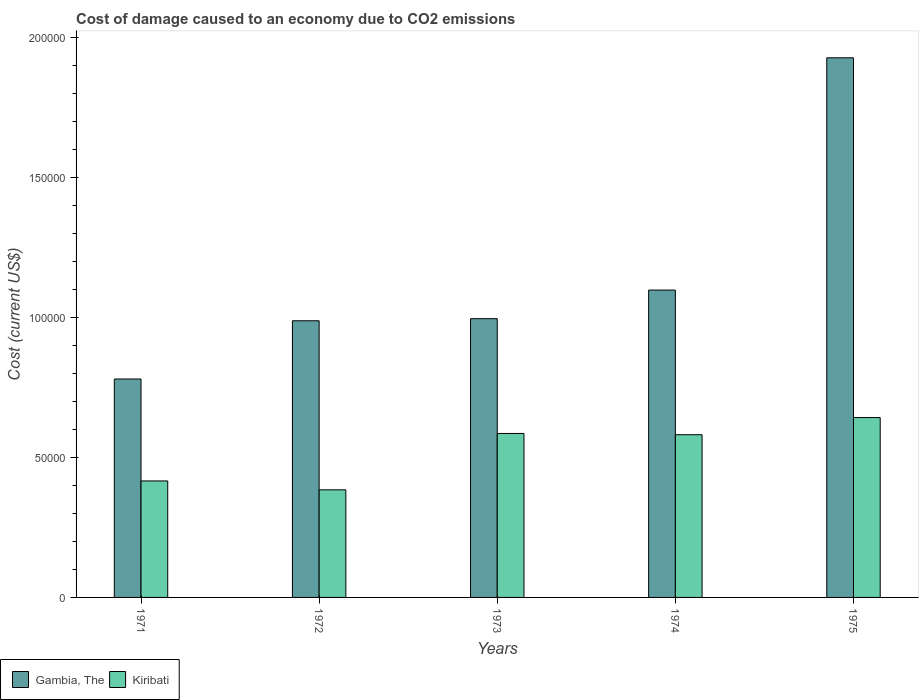How many groups of bars are there?
Ensure brevity in your answer.  5. Are the number of bars per tick equal to the number of legend labels?
Keep it short and to the point. Yes. How many bars are there on the 1st tick from the left?
Your response must be concise. 2. How many bars are there on the 1st tick from the right?
Keep it short and to the point. 2. What is the label of the 3rd group of bars from the left?
Keep it short and to the point. 1973. In how many cases, is the number of bars for a given year not equal to the number of legend labels?
Offer a terse response. 0. What is the cost of damage caused due to CO2 emissisons in Gambia, The in 1971?
Offer a very short reply. 7.81e+04. Across all years, what is the maximum cost of damage caused due to CO2 emissisons in Gambia, The?
Your answer should be compact. 1.93e+05. Across all years, what is the minimum cost of damage caused due to CO2 emissisons in Kiribati?
Offer a terse response. 3.84e+04. In which year was the cost of damage caused due to CO2 emissisons in Kiribati maximum?
Offer a very short reply. 1975. What is the total cost of damage caused due to CO2 emissisons in Gambia, The in the graph?
Provide a succinct answer. 5.79e+05. What is the difference between the cost of damage caused due to CO2 emissisons in Kiribati in 1973 and that in 1975?
Make the answer very short. -5685.38. What is the difference between the cost of damage caused due to CO2 emissisons in Gambia, The in 1973 and the cost of damage caused due to CO2 emissisons in Kiribati in 1972?
Give a very brief answer. 6.12e+04. What is the average cost of damage caused due to CO2 emissisons in Kiribati per year?
Offer a very short reply. 5.22e+04. In the year 1971, what is the difference between the cost of damage caused due to CO2 emissisons in Gambia, The and cost of damage caused due to CO2 emissisons in Kiribati?
Your answer should be compact. 3.64e+04. In how many years, is the cost of damage caused due to CO2 emissisons in Gambia, The greater than 30000 US$?
Your answer should be very brief. 5. What is the ratio of the cost of damage caused due to CO2 emissisons in Kiribati in 1972 to that in 1974?
Offer a very short reply. 0.66. Is the cost of damage caused due to CO2 emissisons in Gambia, The in 1971 less than that in 1974?
Make the answer very short. Yes. Is the difference between the cost of damage caused due to CO2 emissisons in Gambia, The in 1973 and 1974 greater than the difference between the cost of damage caused due to CO2 emissisons in Kiribati in 1973 and 1974?
Offer a very short reply. No. What is the difference between the highest and the second highest cost of damage caused due to CO2 emissisons in Gambia, The?
Provide a succinct answer. 8.30e+04. What is the difference between the highest and the lowest cost of damage caused due to CO2 emissisons in Kiribati?
Offer a terse response. 2.58e+04. In how many years, is the cost of damage caused due to CO2 emissisons in Gambia, The greater than the average cost of damage caused due to CO2 emissisons in Gambia, The taken over all years?
Your answer should be very brief. 1. What does the 1st bar from the left in 1975 represents?
Offer a very short reply. Gambia, The. What does the 1st bar from the right in 1975 represents?
Give a very brief answer. Kiribati. How many bars are there?
Your answer should be compact. 10. Are all the bars in the graph horizontal?
Your answer should be very brief. No. How many legend labels are there?
Offer a very short reply. 2. What is the title of the graph?
Your response must be concise. Cost of damage caused to an economy due to CO2 emissions. Does "United Arab Emirates" appear as one of the legend labels in the graph?
Your answer should be very brief. No. What is the label or title of the Y-axis?
Your answer should be compact. Cost (current US$). What is the Cost (current US$) in Gambia, The in 1971?
Ensure brevity in your answer.  7.81e+04. What is the Cost (current US$) of Kiribati in 1971?
Make the answer very short. 4.16e+04. What is the Cost (current US$) in Gambia, The in 1972?
Your answer should be compact. 9.89e+04. What is the Cost (current US$) in Kiribati in 1972?
Your answer should be very brief. 3.84e+04. What is the Cost (current US$) of Gambia, The in 1973?
Your answer should be very brief. 9.96e+04. What is the Cost (current US$) of Kiribati in 1973?
Your answer should be compact. 5.86e+04. What is the Cost (current US$) of Gambia, The in 1974?
Provide a succinct answer. 1.10e+05. What is the Cost (current US$) of Kiribati in 1974?
Provide a short and direct response. 5.82e+04. What is the Cost (current US$) in Gambia, The in 1975?
Offer a terse response. 1.93e+05. What is the Cost (current US$) of Kiribati in 1975?
Provide a short and direct response. 6.43e+04. Across all years, what is the maximum Cost (current US$) of Gambia, The?
Make the answer very short. 1.93e+05. Across all years, what is the maximum Cost (current US$) in Kiribati?
Your response must be concise. 6.43e+04. Across all years, what is the minimum Cost (current US$) of Gambia, The?
Offer a very short reply. 7.81e+04. Across all years, what is the minimum Cost (current US$) of Kiribati?
Provide a succinct answer. 3.84e+04. What is the total Cost (current US$) of Gambia, The in the graph?
Provide a short and direct response. 5.79e+05. What is the total Cost (current US$) in Kiribati in the graph?
Make the answer very short. 2.61e+05. What is the difference between the Cost (current US$) in Gambia, The in 1971 and that in 1972?
Provide a succinct answer. -2.08e+04. What is the difference between the Cost (current US$) in Kiribati in 1971 and that in 1972?
Make the answer very short. 3180.12. What is the difference between the Cost (current US$) of Gambia, The in 1971 and that in 1973?
Make the answer very short. -2.16e+04. What is the difference between the Cost (current US$) in Kiribati in 1971 and that in 1973?
Your answer should be very brief. -1.70e+04. What is the difference between the Cost (current US$) of Gambia, The in 1971 and that in 1974?
Provide a succinct answer. -3.18e+04. What is the difference between the Cost (current US$) of Kiribati in 1971 and that in 1974?
Your answer should be very brief. -1.65e+04. What is the difference between the Cost (current US$) in Gambia, The in 1971 and that in 1975?
Give a very brief answer. -1.15e+05. What is the difference between the Cost (current US$) in Kiribati in 1971 and that in 1975?
Keep it short and to the point. -2.27e+04. What is the difference between the Cost (current US$) of Gambia, The in 1972 and that in 1973?
Provide a succinct answer. -745.13. What is the difference between the Cost (current US$) of Kiribati in 1972 and that in 1973?
Make the answer very short. -2.01e+04. What is the difference between the Cost (current US$) of Gambia, The in 1972 and that in 1974?
Your answer should be very brief. -1.10e+04. What is the difference between the Cost (current US$) in Kiribati in 1972 and that in 1974?
Offer a very short reply. -1.97e+04. What is the difference between the Cost (current US$) in Gambia, The in 1972 and that in 1975?
Keep it short and to the point. -9.40e+04. What is the difference between the Cost (current US$) of Kiribati in 1972 and that in 1975?
Offer a terse response. -2.58e+04. What is the difference between the Cost (current US$) in Gambia, The in 1973 and that in 1974?
Your answer should be very brief. -1.02e+04. What is the difference between the Cost (current US$) of Kiribati in 1973 and that in 1974?
Your response must be concise. 446.66. What is the difference between the Cost (current US$) in Gambia, The in 1973 and that in 1975?
Offer a very short reply. -9.32e+04. What is the difference between the Cost (current US$) in Kiribati in 1973 and that in 1975?
Offer a terse response. -5685.38. What is the difference between the Cost (current US$) in Gambia, The in 1974 and that in 1975?
Offer a very short reply. -8.30e+04. What is the difference between the Cost (current US$) in Kiribati in 1974 and that in 1975?
Your answer should be very brief. -6132.04. What is the difference between the Cost (current US$) in Gambia, The in 1971 and the Cost (current US$) in Kiribati in 1972?
Provide a short and direct response. 3.96e+04. What is the difference between the Cost (current US$) in Gambia, The in 1971 and the Cost (current US$) in Kiribati in 1973?
Provide a succinct answer. 1.95e+04. What is the difference between the Cost (current US$) in Gambia, The in 1971 and the Cost (current US$) in Kiribati in 1974?
Your answer should be compact. 1.99e+04. What is the difference between the Cost (current US$) of Gambia, The in 1971 and the Cost (current US$) of Kiribati in 1975?
Your answer should be compact. 1.38e+04. What is the difference between the Cost (current US$) of Gambia, The in 1972 and the Cost (current US$) of Kiribati in 1973?
Offer a terse response. 4.03e+04. What is the difference between the Cost (current US$) of Gambia, The in 1972 and the Cost (current US$) of Kiribati in 1974?
Provide a short and direct response. 4.07e+04. What is the difference between the Cost (current US$) in Gambia, The in 1972 and the Cost (current US$) in Kiribati in 1975?
Your response must be concise. 3.46e+04. What is the difference between the Cost (current US$) of Gambia, The in 1973 and the Cost (current US$) of Kiribati in 1974?
Provide a short and direct response. 4.15e+04. What is the difference between the Cost (current US$) of Gambia, The in 1973 and the Cost (current US$) of Kiribati in 1975?
Provide a short and direct response. 3.53e+04. What is the difference between the Cost (current US$) in Gambia, The in 1974 and the Cost (current US$) in Kiribati in 1975?
Your response must be concise. 4.56e+04. What is the average Cost (current US$) in Gambia, The per year?
Ensure brevity in your answer.  1.16e+05. What is the average Cost (current US$) in Kiribati per year?
Offer a very short reply. 5.22e+04. In the year 1971, what is the difference between the Cost (current US$) in Gambia, The and Cost (current US$) in Kiribati?
Your answer should be compact. 3.64e+04. In the year 1972, what is the difference between the Cost (current US$) in Gambia, The and Cost (current US$) in Kiribati?
Make the answer very short. 6.04e+04. In the year 1973, what is the difference between the Cost (current US$) of Gambia, The and Cost (current US$) of Kiribati?
Provide a short and direct response. 4.10e+04. In the year 1974, what is the difference between the Cost (current US$) of Gambia, The and Cost (current US$) of Kiribati?
Your response must be concise. 5.17e+04. In the year 1975, what is the difference between the Cost (current US$) in Gambia, The and Cost (current US$) in Kiribati?
Give a very brief answer. 1.29e+05. What is the ratio of the Cost (current US$) in Gambia, The in 1971 to that in 1972?
Your answer should be compact. 0.79. What is the ratio of the Cost (current US$) of Kiribati in 1971 to that in 1972?
Your answer should be very brief. 1.08. What is the ratio of the Cost (current US$) of Gambia, The in 1971 to that in 1973?
Your response must be concise. 0.78. What is the ratio of the Cost (current US$) in Kiribati in 1971 to that in 1973?
Keep it short and to the point. 0.71. What is the ratio of the Cost (current US$) in Gambia, The in 1971 to that in 1974?
Your response must be concise. 0.71. What is the ratio of the Cost (current US$) in Kiribati in 1971 to that in 1974?
Give a very brief answer. 0.72. What is the ratio of the Cost (current US$) of Gambia, The in 1971 to that in 1975?
Offer a very short reply. 0.4. What is the ratio of the Cost (current US$) of Kiribati in 1971 to that in 1975?
Keep it short and to the point. 0.65. What is the ratio of the Cost (current US$) of Gambia, The in 1972 to that in 1973?
Give a very brief answer. 0.99. What is the ratio of the Cost (current US$) of Kiribati in 1972 to that in 1973?
Give a very brief answer. 0.66. What is the ratio of the Cost (current US$) in Gambia, The in 1972 to that in 1974?
Your response must be concise. 0.9. What is the ratio of the Cost (current US$) of Kiribati in 1972 to that in 1974?
Give a very brief answer. 0.66. What is the ratio of the Cost (current US$) of Gambia, The in 1972 to that in 1975?
Your answer should be very brief. 0.51. What is the ratio of the Cost (current US$) of Kiribati in 1972 to that in 1975?
Provide a succinct answer. 0.6. What is the ratio of the Cost (current US$) of Gambia, The in 1973 to that in 1974?
Provide a short and direct response. 0.91. What is the ratio of the Cost (current US$) of Kiribati in 1973 to that in 1974?
Ensure brevity in your answer.  1.01. What is the ratio of the Cost (current US$) in Gambia, The in 1973 to that in 1975?
Your answer should be compact. 0.52. What is the ratio of the Cost (current US$) in Kiribati in 1973 to that in 1975?
Give a very brief answer. 0.91. What is the ratio of the Cost (current US$) in Gambia, The in 1974 to that in 1975?
Offer a very short reply. 0.57. What is the ratio of the Cost (current US$) of Kiribati in 1974 to that in 1975?
Your response must be concise. 0.9. What is the difference between the highest and the second highest Cost (current US$) of Gambia, The?
Provide a short and direct response. 8.30e+04. What is the difference between the highest and the second highest Cost (current US$) in Kiribati?
Provide a succinct answer. 5685.38. What is the difference between the highest and the lowest Cost (current US$) of Gambia, The?
Your answer should be compact. 1.15e+05. What is the difference between the highest and the lowest Cost (current US$) of Kiribati?
Give a very brief answer. 2.58e+04. 